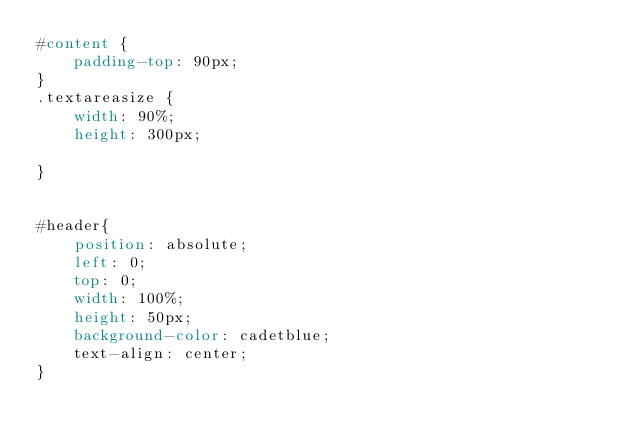<code> <loc_0><loc_0><loc_500><loc_500><_CSS_>#content {
    padding-top: 90px;
}
.textareasize {
    width: 90%;
    height: 300px;

}


#header{
    position: absolute;
    left: 0;
    top: 0;
    width: 100%;
    height: 50px;
    background-color: cadetblue;
    text-align: center;
}
</code> 